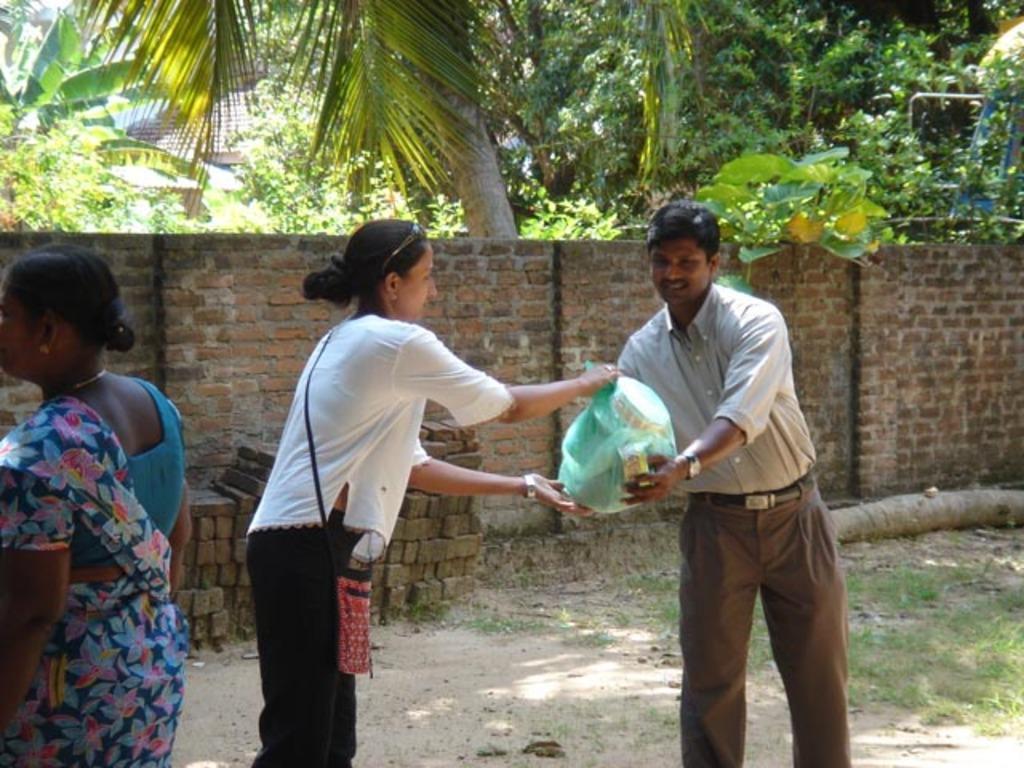Could you give a brief overview of what you see in this image? In the picture I can see a man and two women are standing on the ground. The man and a woman is are holding some object in hands. In the background I can see a fence wall, trees, the grass, a house, bricks on the ground and some other objects. 